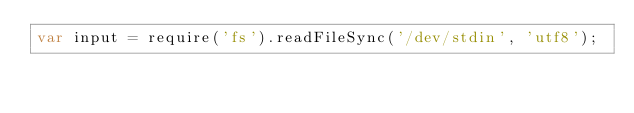<code> <loc_0><loc_0><loc_500><loc_500><_JavaScript_>var input = require('fs').readFileSync('/dev/stdin', 'utf8');</code> 